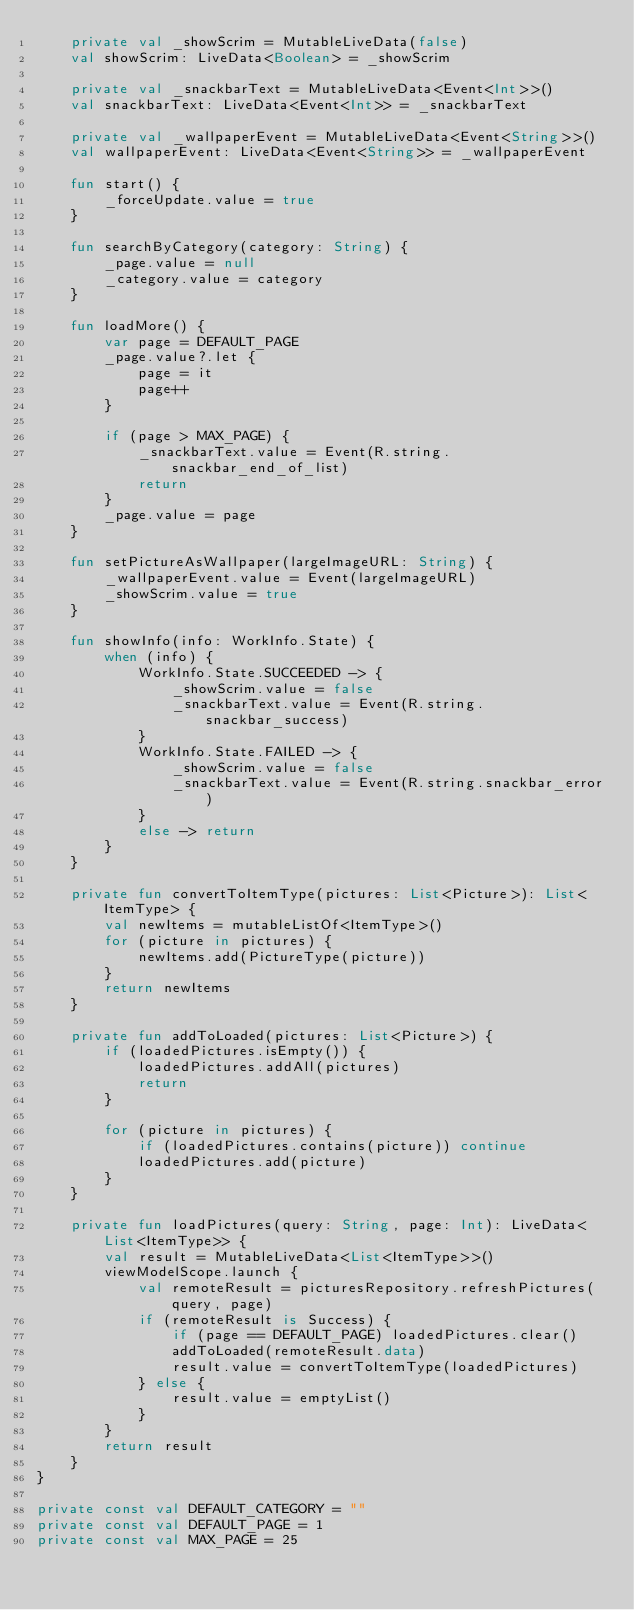Convert code to text. <code><loc_0><loc_0><loc_500><loc_500><_Kotlin_>    private val _showScrim = MutableLiveData(false)
    val showScrim: LiveData<Boolean> = _showScrim

    private val _snackbarText = MutableLiveData<Event<Int>>()
    val snackbarText: LiveData<Event<Int>> = _snackbarText

    private val _wallpaperEvent = MutableLiveData<Event<String>>()
    val wallpaperEvent: LiveData<Event<String>> = _wallpaperEvent

    fun start() {
        _forceUpdate.value = true
    }

    fun searchByCategory(category: String) {
        _page.value = null
        _category.value = category
    }

    fun loadMore() {
        var page = DEFAULT_PAGE
        _page.value?.let {
            page = it
            page++
        }

        if (page > MAX_PAGE) {
            _snackbarText.value = Event(R.string.snackbar_end_of_list)
            return
        }
        _page.value = page
    }

    fun setPictureAsWallpaper(largeImageURL: String) {
        _wallpaperEvent.value = Event(largeImageURL)
        _showScrim.value = true
    }

    fun showInfo(info: WorkInfo.State) {
        when (info) {
            WorkInfo.State.SUCCEEDED -> {
                _showScrim.value = false
                _snackbarText.value = Event(R.string.snackbar_success)
            }
            WorkInfo.State.FAILED -> {
                _showScrim.value = false
                _snackbarText.value = Event(R.string.snackbar_error)
            }
            else -> return
        }
    }

    private fun convertToItemType(pictures: List<Picture>): List<ItemType> {
        val newItems = mutableListOf<ItemType>()
        for (picture in pictures) {
            newItems.add(PictureType(picture))
        }
        return newItems
    }

    private fun addToLoaded(pictures: List<Picture>) {
        if (loadedPictures.isEmpty()) {
            loadedPictures.addAll(pictures)
            return
        }

        for (picture in pictures) {
            if (loadedPictures.contains(picture)) continue
            loadedPictures.add(picture)
        }
    }

    private fun loadPictures(query: String, page: Int): LiveData<List<ItemType>> {
        val result = MutableLiveData<List<ItemType>>()
        viewModelScope.launch {
            val remoteResult = picturesRepository.refreshPictures(query, page)
            if (remoteResult is Success) {
                if (page == DEFAULT_PAGE) loadedPictures.clear()
                addToLoaded(remoteResult.data)
                result.value = convertToItemType(loadedPictures)
            } else {
                result.value = emptyList()
            }
        }
        return result
    }
}

private const val DEFAULT_CATEGORY = ""
private const val DEFAULT_PAGE = 1
private const val MAX_PAGE = 25</code> 